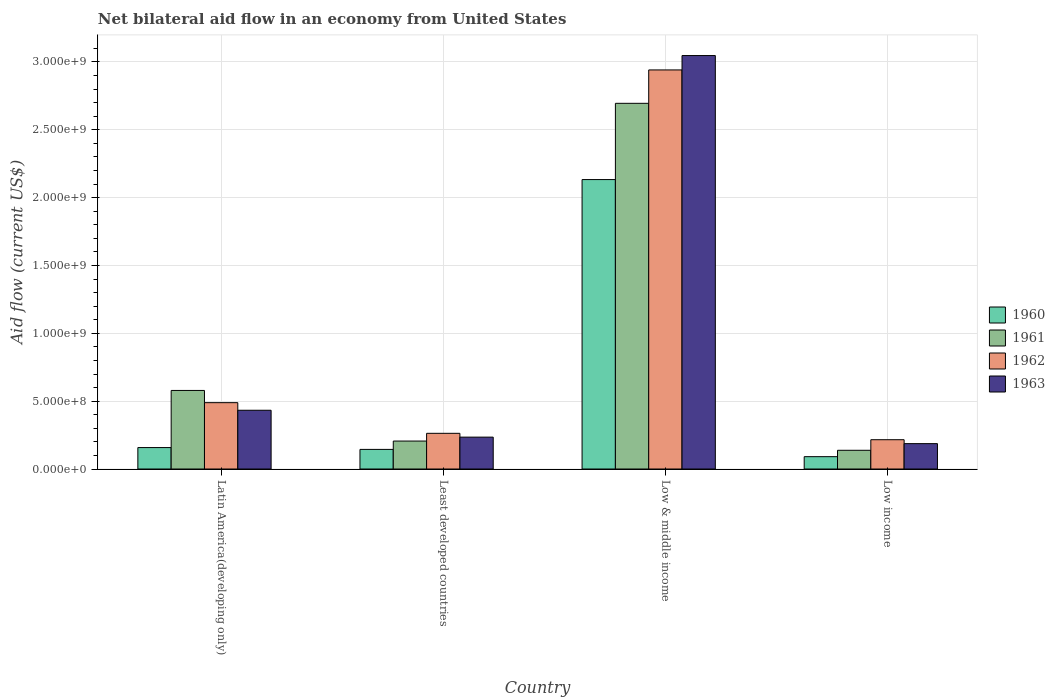How many groups of bars are there?
Your answer should be very brief. 4. Are the number of bars per tick equal to the number of legend labels?
Give a very brief answer. Yes. How many bars are there on the 1st tick from the left?
Offer a terse response. 4. What is the label of the 3rd group of bars from the left?
Your answer should be very brief. Low & middle income. In how many cases, is the number of bars for a given country not equal to the number of legend labels?
Keep it short and to the point. 0. What is the net bilateral aid flow in 1962 in Least developed countries?
Offer a very short reply. 2.63e+08. Across all countries, what is the maximum net bilateral aid flow in 1962?
Your response must be concise. 2.94e+09. Across all countries, what is the minimum net bilateral aid flow in 1963?
Provide a short and direct response. 1.87e+08. In which country was the net bilateral aid flow in 1963 maximum?
Your response must be concise. Low & middle income. What is the total net bilateral aid flow in 1962 in the graph?
Provide a succinct answer. 3.91e+09. What is the difference between the net bilateral aid flow in 1962 in Least developed countries and that in Low income?
Keep it short and to the point. 4.70e+07. What is the difference between the net bilateral aid flow in 1961 in Low & middle income and the net bilateral aid flow in 1962 in Low income?
Give a very brief answer. 2.48e+09. What is the average net bilateral aid flow in 1961 per country?
Provide a succinct answer. 9.04e+08. What is the difference between the net bilateral aid flow of/in 1960 and net bilateral aid flow of/in 1961 in Latin America(developing only)?
Offer a terse response. -4.21e+08. In how many countries, is the net bilateral aid flow in 1961 greater than 1000000000 US$?
Your answer should be compact. 1. What is the ratio of the net bilateral aid flow in 1961 in Least developed countries to that in Low & middle income?
Keep it short and to the point. 0.08. What is the difference between the highest and the second highest net bilateral aid flow in 1962?
Your answer should be compact. 2.45e+09. What is the difference between the highest and the lowest net bilateral aid flow in 1961?
Provide a short and direct response. 2.56e+09. In how many countries, is the net bilateral aid flow in 1962 greater than the average net bilateral aid flow in 1962 taken over all countries?
Keep it short and to the point. 1. Is the sum of the net bilateral aid flow in 1962 in Least developed countries and Low & middle income greater than the maximum net bilateral aid flow in 1961 across all countries?
Make the answer very short. Yes. Is it the case that in every country, the sum of the net bilateral aid flow in 1963 and net bilateral aid flow in 1961 is greater than the sum of net bilateral aid flow in 1962 and net bilateral aid flow in 1960?
Your answer should be very brief. No. What does the 3rd bar from the left in Low income represents?
Keep it short and to the point. 1962. What does the 4th bar from the right in Low & middle income represents?
Make the answer very short. 1960. Are all the bars in the graph horizontal?
Provide a short and direct response. No. How many countries are there in the graph?
Your answer should be very brief. 4. Does the graph contain grids?
Your response must be concise. Yes. What is the title of the graph?
Keep it short and to the point. Net bilateral aid flow in an economy from United States. Does "1960" appear as one of the legend labels in the graph?
Your response must be concise. Yes. What is the label or title of the Y-axis?
Your response must be concise. Aid flow (current US$). What is the Aid flow (current US$) of 1960 in Latin America(developing only)?
Ensure brevity in your answer.  1.58e+08. What is the Aid flow (current US$) of 1961 in Latin America(developing only)?
Ensure brevity in your answer.  5.79e+08. What is the Aid flow (current US$) of 1962 in Latin America(developing only)?
Offer a very short reply. 4.89e+08. What is the Aid flow (current US$) of 1963 in Latin America(developing only)?
Provide a short and direct response. 4.33e+08. What is the Aid flow (current US$) of 1960 in Least developed countries?
Provide a succinct answer. 1.45e+08. What is the Aid flow (current US$) in 1961 in Least developed countries?
Your response must be concise. 2.06e+08. What is the Aid flow (current US$) in 1962 in Least developed countries?
Give a very brief answer. 2.63e+08. What is the Aid flow (current US$) of 1963 in Least developed countries?
Ensure brevity in your answer.  2.35e+08. What is the Aid flow (current US$) in 1960 in Low & middle income?
Your answer should be very brief. 2.13e+09. What is the Aid flow (current US$) in 1961 in Low & middle income?
Provide a short and direct response. 2.70e+09. What is the Aid flow (current US$) in 1962 in Low & middle income?
Provide a short and direct response. 2.94e+09. What is the Aid flow (current US$) of 1963 in Low & middle income?
Your answer should be compact. 3.05e+09. What is the Aid flow (current US$) of 1960 in Low income?
Offer a very short reply. 9.10e+07. What is the Aid flow (current US$) in 1961 in Low income?
Your answer should be compact. 1.38e+08. What is the Aid flow (current US$) of 1962 in Low income?
Provide a short and direct response. 2.16e+08. What is the Aid flow (current US$) in 1963 in Low income?
Your response must be concise. 1.87e+08. Across all countries, what is the maximum Aid flow (current US$) in 1960?
Give a very brief answer. 2.13e+09. Across all countries, what is the maximum Aid flow (current US$) of 1961?
Make the answer very short. 2.70e+09. Across all countries, what is the maximum Aid flow (current US$) in 1962?
Your response must be concise. 2.94e+09. Across all countries, what is the maximum Aid flow (current US$) in 1963?
Give a very brief answer. 3.05e+09. Across all countries, what is the minimum Aid flow (current US$) of 1960?
Your answer should be very brief. 9.10e+07. Across all countries, what is the minimum Aid flow (current US$) in 1961?
Your answer should be compact. 1.38e+08. Across all countries, what is the minimum Aid flow (current US$) in 1962?
Keep it short and to the point. 2.16e+08. Across all countries, what is the minimum Aid flow (current US$) in 1963?
Give a very brief answer. 1.87e+08. What is the total Aid flow (current US$) of 1960 in the graph?
Your response must be concise. 2.53e+09. What is the total Aid flow (current US$) of 1961 in the graph?
Make the answer very short. 3.62e+09. What is the total Aid flow (current US$) in 1962 in the graph?
Provide a succinct answer. 3.91e+09. What is the total Aid flow (current US$) of 1963 in the graph?
Your answer should be very brief. 3.90e+09. What is the difference between the Aid flow (current US$) of 1960 in Latin America(developing only) and that in Least developed countries?
Provide a succinct answer. 1.35e+07. What is the difference between the Aid flow (current US$) of 1961 in Latin America(developing only) and that in Least developed countries?
Give a very brief answer. 3.73e+08. What is the difference between the Aid flow (current US$) of 1962 in Latin America(developing only) and that in Least developed countries?
Ensure brevity in your answer.  2.26e+08. What is the difference between the Aid flow (current US$) in 1963 in Latin America(developing only) and that in Least developed countries?
Provide a succinct answer. 1.98e+08. What is the difference between the Aid flow (current US$) of 1960 in Latin America(developing only) and that in Low & middle income?
Keep it short and to the point. -1.98e+09. What is the difference between the Aid flow (current US$) of 1961 in Latin America(developing only) and that in Low & middle income?
Your answer should be very brief. -2.12e+09. What is the difference between the Aid flow (current US$) of 1962 in Latin America(developing only) and that in Low & middle income?
Provide a short and direct response. -2.45e+09. What is the difference between the Aid flow (current US$) in 1963 in Latin America(developing only) and that in Low & middle income?
Offer a terse response. -2.61e+09. What is the difference between the Aid flow (current US$) of 1960 in Latin America(developing only) and that in Low income?
Your answer should be very brief. 6.70e+07. What is the difference between the Aid flow (current US$) in 1961 in Latin America(developing only) and that in Low income?
Your response must be concise. 4.41e+08. What is the difference between the Aid flow (current US$) in 1962 in Latin America(developing only) and that in Low income?
Offer a very short reply. 2.73e+08. What is the difference between the Aid flow (current US$) of 1963 in Latin America(developing only) and that in Low income?
Offer a very short reply. 2.46e+08. What is the difference between the Aid flow (current US$) in 1960 in Least developed countries and that in Low & middle income?
Make the answer very short. -1.99e+09. What is the difference between the Aid flow (current US$) of 1961 in Least developed countries and that in Low & middle income?
Your answer should be compact. -2.49e+09. What is the difference between the Aid flow (current US$) of 1962 in Least developed countries and that in Low & middle income?
Provide a succinct answer. -2.68e+09. What is the difference between the Aid flow (current US$) of 1963 in Least developed countries and that in Low & middle income?
Ensure brevity in your answer.  -2.81e+09. What is the difference between the Aid flow (current US$) of 1960 in Least developed countries and that in Low income?
Keep it short and to the point. 5.35e+07. What is the difference between the Aid flow (current US$) in 1961 in Least developed countries and that in Low income?
Ensure brevity in your answer.  6.80e+07. What is the difference between the Aid flow (current US$) in 1962 in Least developed countries and that in Low income?
Offer a very short reply. 4.70e+07. What is the difference between the Aid flow (current US$) in 1963 in Least developed countries and that in Low income?
Offer a terse response. 4.80e+07. What is the difference between the Aid flow (current US$) in 1960 in Low & middle income and that in Low income?
Make the answer very short. 2.04e+09. What is the difference between the Aid flow (current US$) of 1961 in Low & middle income and that in Low income?
Give a very brief answer. 2.56e+09. What is the difference between the Aid flow (current US$) of 1962 in Low & middle income and that in Low income?
Give a very brief answer. 2.72e+09. What is the difference between the Aid flow (current US$) in 1963 in Low & middle income and that in Low income?
Provide a succinct answer. 2.86e+09. What is the difference between the Aid flow (current US$) of 1960 in Latin America(developing only) and the Aid flow (current US$) of 1961 in Least developed countries?
Keep it short and to the point. -4.80e+07. What is the difference between the Aid flow (current US$) in 1960 in Latin America(developing only) and the Aid flow (current US$) in 1962 in Least developed countries?
Offer a terse response. -1.05e+08. What is the difference between the Aid flow (current US$) in 1960 in Latin America(developing only) and the Aid flow (current US$) in 1963 in Least developed countries?
Provide a succinct answer. -7.70e+07. What is the difference between the Aid flow (current US$) of 1961 in Latin America(developing only) and the Aid flow (current US$) of 1962 in Least developed countries?
Offer a terse response. 3.16e+08. What is the difference between the Aid flow (current US$) in 1961 in Latin America(developing only) and the Aid flow (current US$) in 1963 in Least developed countries?
Keep it short and to the point. 3.44e+08. What is the difference between the Aid flow (current US$) in 1962 in Latin America(developing only) and the Aid flow (current US$) in 1963 in Least developed countries?
Offer a very short reply. 2.54e+08. What is the difference between the Aid flow (current US$) in 1960 in Latin America(developing only) and the Aid flow (current US$) in 1961 in Low & middle income?
Provide a succinct answer. -2.54e+09. What is the difference between the Aid flow (current US$) in 1960 in Latin America(developing only) and the Aid flow (current US$) in 1962 in Low & middle income?
Your response must be concise. -2.78e+09. What is the difference between the Aid flow (current US$) of 1960 in Latin America(developing only) and the Aid flow (current US$) of 1963 in Low & middle income?
Ensure brevity in your answer.  -2.89e+09. What is the difference between the Aid flow (current US$) of 1961 in Latin America(developing only) and the Aid flow (current US$) of 1962 in Low & middle income?
Make the answer very short. -2.36e+09. What is the difference between the Aid flow (current US$) of 1961 in Latin America(developing only) and the Aid flow (current US$) of 1963 in Low & middle income?
Give a very brief answer. -2.47e+09. What is the difference between the Aid flow (current US$) in 1962 in Latin America(developing only) and the Aid flow (current US$) in 1963 in Low & middle income?
Your response must be concise. -2.56e+09. What is the difference between the Aid flow (current US$) in 1960 in Latin America(developing only) and the Aid flow (current US$) in 1962 in Low income?
Offer a terse response. -5.80e+07. What is the difference between the Aid flow (current US$) of 1960 in Latin America(developing only) and the Aid flow (current US$) of 1963 in Low income?
Your answer should be very brief. -2.90e+07. What is the difference between the Aid flow (current US$) in 1961 in Latin America(developing only) and the Aid flow (current US$) in 1962 in Low income?
Provide a succinct answer. 3.63e+08. What is the difference between the Aid flow (current US$) in 1961 in Latin America(developing only) and the Aid flow (current US$) in 1963 in Low income?
Your answer should be very brief. 3.92e+08. What is the difference between the Aid flow (current US$) of 1962 in Latin America(developing only) and the Aid flow (current US$) of 1963 in Low income?
Your response must be concise. 3.02e+08. What is the difference between the Aid flow (current US$) of 1960 in Least developed countries and the Aid flow (current US$) of 1961 in Low & middle income?
Offer a very short reply. -2.55e+09. What is the difference between the Aid flow (current US$) in 1960 in Least developed countries and the Aid flow (current US$) in 1962 in Low & middle income?
Make the answer very short. -2.80e+09. What is the difference between the Aid flow (current US$) in 1960 in Least developed countries and the Aid flow (current US$) in 1963 in Low & middle income?
Your response must be concise. -2.90e+09. What is the difference between the Aid flow (current US$) in 1961 in Least developed countries and the Aid flow (current US$) in 1962 in Low & middle income?
Give a very brief answer. -2.74e+09. What is the difference between the Aid flow (current US$) of 1961 in Least developed countries and the Aid flow (current US$) of 1963 in Low & middle income?
Make the answer very short. -2.84e+09. What is the difference between the Aid flow (current US$) in 1962 in Least developed countries and the Aid flow (current US$) in 1963 in Low & middle income?
Provide a succinct answer. -2.78e+09. What is the difference between the Aid flow (current US$) of 1960 in Least developed countries and the Aid flow (current US$) of 1961 in Low income?
Your answer should be very brief. 6.52e+06. What is the difference between the Aid flow (current US$) in 1960 in Least developed countries and the Aid flow (current US$) in 1962 in Low income?
Ensure brevity in your answer.  -7.15e+07. What is the difference between the Aid flow (current US$) in 1960 in Least developed countries and the Aid flow (current US$) in 1963 in Low income?
Give a very brief answer. -4.25e+07. What is the difference between the Aid flow (current US$) in 1961 in Least developed countries and the Aid flow (current US$) in 1962 in Low income?
Your answer should be very brief. -1.00e+07. What is the difference between the Aid flow (current US$) in 1961 in Least developed countries and the Aid flow (current US$) in 1963 in Low income?
Give a very brief answer. 1.90e+07. What is the difference between the Aid flow (current US$) in 1962 in Least developed countries and the Aid flow (current US$) in 1963 in Low income?
Your answer should be compact. 7.60e+07. What is the difference between the Aid flow (current US$) of 1960 in Low & middle income and the Aid flow (current US$) of 1961 in Low income?
Offer a terse response. 2.00e+09. What is the difference between the Aid flow (current US$) in 1960 in Low & middle income and the Aid flow (current US$) in 1962 in Low income?
Offer a very short reply. 1.92e+09. What is the difference between the Aid flow (current US$) of 1960 in Low & middle income and the Aid flow (current US$) of 1963 in Low income?
Keep it short and to the point. 1.95e+09. What is the difference between the Aid flow (current US$) of 1961 in Low & middle income and the Aid flow (current US$) of 1962 in Low income?
Provide a succinct answer. 2.48e+09. What is the difference between the Aid flow (current US$) of 1961 in Low & middle income and the Aid flow (current US$) of 1963 in Low income?
Make the answer very short. 2.51e+09. What is the difference between the Aid flow (current US$) in 1962 in Low & middle income and the Aid flow (current US$) in 1963 in Low income?
Ensure brevity in your answer.  2.75e+09. What is the average Aid flow (current US$) in 1960 per country?
Your response must be concise. 6.32e+08. What is the average Aid flow (current US$) in 1961 per country?
Make the answer very short. 9.04e+08. What is the average Aid flow (current US$) in 1962 per country?
Ensure brevity in your answer.  9.77e+08. What is the average Aid flow (current US$) of 1963 per country?
Your response must be concise. 9.76e+08. What is the difference between the Aid flow (current US$) of 1960 and Aid flow (current US$) of 1961 in Latin America(developing only)?
Offer a terse response. -4.21e+08. What is the difference between the Aid flow (current US$) in 1960 and Aid flow (current US$) in 1962 in Latin America(developing only)?
Make the answer very short. -3.31e+08. What is the difference between the Aid flow (current US$) in 1960 and Aid flow (current US$) in 1963 in Latin America(developing only)?
Your response must be concise. -2.75e+08. What is the difference between the Aid flow (current US$) in 1961 and Aid flow (current US$) in 1962 in Latin America(developing only)?
Offer a terse response. 9.00e+07. What is the difference between the Aid flow (current US$) of 1961 and Aid flow (current US$) of 1963 in Latin America(developing only)?
Give a very brief answer. 1.46e+08. What is the difference between the Aid flow (current US$) of 1962 and Aid flow (current US$) of 1963 in Latin America(developing only)?
Offer a terse response. 5.60e+07. What is the difference between the Aid flow (current US$) in 1960 and Aid flow (current US$) in 1961 in Least developed countries?
Your answer should be compact. -6.15e+07. What is the difference between the Aid flow (current US$) of 1960 and Aid flow (current US$) of 1962 in Least developed countries?
Your answer should be very brief. -1.18e+08. What is the difference between the Aid flow (current US$) of 1960 and Aid flow (current US$) of 1963 in Least developed countries?
Offer a very short reply. -9.05e+07. What is the difference between the Aid flow (current US$) in 1961 and Aid flow (current US$) in 1962 in Least developed countries?
Provide a short and direct response. -5.70e+07. What is the difference between the Aid flow (current US$) in 1961 and Aid flow (current US$) in 1963 in Least developed countries?
Your answer should be very brief. -2.90e+07. What is the difference between the Aid flow (current US$) of 1962 and Aid flow (current US$) of 1963 in Least developed countries?
Your answer should be very brief. 2.80e+07. What is the difference between the Aid flow (current US$) in 1960 and Aid flow (current US$) in 1961 in Low & middle income?
Your answer should be compact. -5.62e+08. What is the difference between the Aid flow (current US$) of 1960 and Aid flow (current US$) of 1962 in Low & middle income?
Give a very brief answer. -8.08e+08. What is the difference between the Aid flow (current US$) in 1960 and Aid flow (current US$) in 1963 in Low & middle income?
Your answer should be compact. -9.14e+08. What is the difference between the Aid flow (current US$) of 1961 and Aid flow (current US$) of 1962 in Low & middle income?
Your answer should be very brief. -2.46e+08. What is the difference between the Aid flow (current US$) in 1961 and Aid flow (current US$) in 1963 in Low & middle income?
Give a very brief answer. -3.52e+08. What is the difference between the Aid flow (current US$) in 1962 and Aid flow (current US$) in 1963 in Low & middle income?
Offer a terse response. -1.06e+08. What is the difference between the Aid flow (current US$) of 1960 and Aid flow (current US$) of 1961 in Low income?
Provide a short and direct response. -4.70e+07. What is the difference between the Aid flow (current US$) of 1960 and Aid flow (current US$) of 1962 in Low income?
Provide a succinct answer. -1.25e+08. What is the difference between the Aid flow (current US$) of 1960 and Aid flow (current US$) of 1963 in Low income?
Offer a very short reply. -9.60e+07. What is the difference between the Aid flow (current US$) of 1961 and Aid flow (current US$) of 1962 in Low income?
Give a very brief answer. -7.80e+07. What is the difference between the Aid flow (current US$) in 1961 and Aid flow (current US$) in 1963 in Low income?
Offer a very short reply. -4.90e+07. What is the difference between the Aid flow (current US$) in 1962 and Aid flow (current US$) in 1963 in Low income?
Provide a short and direct response. 2.90e+07. What is the ratio of the Aid flow (current US$) in 1960 in Latin America(developing only) to that in Least developed countries?
Offer a terse response. 1.09. What is the ratio of the Aid flow (current US$) in 1961 in Latin America(developing only) to that in Least developed countries?
Your answer should be very brief. 2.81. What is the ratio of the Aid flow (current US$) of 1962 in Latin America(developing only) to that in Least developed countries?
Provide a succinct answer. 1.86. What is the ratio of the Aid flow (current US$) in 1963 in Latin America(developing only) to that in Least developed countries?
Make the answer very short. 1.84. What is the ratio of the Aid flow (current US$) in 1960 in Latin America(developing only) to that in Low & middle income?
Keep it short and to the point. 0.07. What is the ratio of the Aid flow (current US$) in 1961 in Latin America(developing only) to that in Low & middle income?
Offer a very short reply. 0.21. What is the ratio of the Aid flow (current US$) of 1962 in Latin America(developing only) to that in Low & middle income?
Ensure brevity in your answer.  0.17. What is the ratio of the Aid flow (current US$) in 1963 in Latin America(developing only) to that in Low & middle income?
Provide a short and direct response. 0.14. What is the ratio of the Aid flow (current US$) in 1960 in Latin America(developing only) to that in Low income?
Keep it short and to the point. 1.74. What is the ratio of the Aid flow (current US$) in 1961 in Latin America(developing only) to that in Low income?
Keep it short and to the point. 4.2. What is the ratio of the Aid flow (current US$) of 1962 in Latin America(developing only) to that in Low income?
Your answer should be compact. 2.26. What is the ratio of the Aid flow (current US$) of 1963 in Latin America(developing only) to that in Low income?
Your answer should be very brief. 2.32. What is the ratio of the Aid flow (current US$) in 1960 in Least developed countries to that in Low & middle income?
Offer a terse response. 0.07. What is the ratio of the Aid flow (current US$) in 1961 in Least developed countries to that in Low & middle income?
Give a very brief answer. 0.08. What is the ratio of the Aid flow (current US$) of 1962 in Least developed countries to that in Low & middle income?
Your answer should be very brief. 0.09. What is the ratio of the Aid flow (current US$) of 1963 in Least developed countries to that in Low & middle income?
Give a very brief answer. 0.08. What is the ratio of the Aid flow (current US$) of 1960 in Least developed countries to that in Low income?
Offer a very short reply. 1.59. What is the ratio of the Aid flow (current US$) of 1961 in Least developed countries to that in Low income?
Ensure brevity in your answer.  1.49. What is the ratio of the Aid flow (current US$) in 1962 in Least developed countries to that in Low income?
Offer a terse response. 1.22. What is the ratio of the Aid flow (current US$) in 1963 in Least developed countries to that in Low income?
Your answer should be very brief. 1.26. What is the ratio of the Aid flow (current US$) of 1960 in Low & middle income to that in Low income?
Keep it short and to the point. 23.44. What is the ratio of the Aid flow (current US$) of 1961 in Low & middle income to that in Low income?
Your response must be concise. 19.53. What is the ratio of the Aid flow (current US$) in 1962 in Low & middle income to that in Low income?
Ensure brevity in your answer.  13.62. What is the ratio of the Aid flow (current US$) in 1963 in Low & middle income to that in Low income?
Offer a terse response. 16.29. What is the difference between the highest and the second highest Aid flow (current US$) in 1960?
Provide a succinct answer. 1.98e+09. What is the difference between the highest and the second highest Aid flow (current US$) in 1961?
Offer a terse response. 2.12e+09. What is the difference between the highest and the second highest Aid flow (current US$) in 1962?
Provide a succinct answer. 2.45e+09. What is the difference between the highest and the second highest Aid flow (current US$) in 1963?
Offer a terse response. 2.61e+09. What is the difference between the highest and the lowest Aid flow (current US$) of 1960?
Provide a succinct answer. 2.04e+09. What is the difference between the highest and the lowest Aid flow (current US$) in 1961?
Ensure brevity in your answer.  2.56e+09. What is the difference between the highest and the lowest Aid flow (current US$) of 1962?
Ensure brevity in your answer.  2.72e+09. What is the difference between the highest and the lowest Aid flow (current US$) in 1963?
Keep it short and to the point. 2.86e+09. 